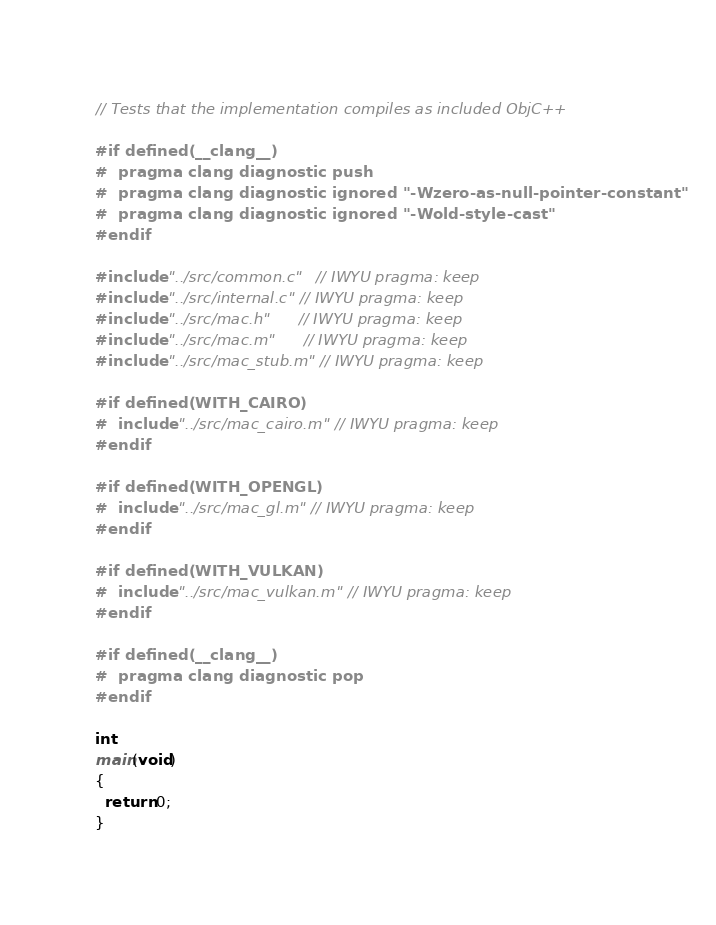<code> <loc_0><loc_0><loc_500><loc_500><_ObjectiveC_>
// Tests that the implementation compiles as included ObjC++

#if defined(__clang__)
#  pragma clang diagnostic push
#  pragma clang diagnostic ignored "-Wzero-as-null-pointer-constant"
#  pragma clang diagnostic ignored "-Wold-style-cast"
#endif

#include "../src/common.c"   // IWYU pragma: keep
#include "../src/internal.c" // IWYU pragma: keep
#include "../src/mac.h"      // IWYU pragma: keep
#include "../src/mac.m"      // IWYU pragma: keep
#include "../src/mac_stub.m" // IWYU pragma: keep

#if defined(WITH_CAIRO)
#  include "../src/mac_cairo.m" // IWYU pragma: keep
#endif

#if defined(WITH_OPENGL)
#  include "../src/mac_gl.m" // IWYU pragma: keep
#endif

#if defined(WITH_VULKAN)
#  include "../src/mac_vulkan.m" // IWYU pragma: keep
#endif

#if defined(__clang__)
#  pragma clang diagnostic pop
#endif

int
main(void)
{
  return 0;
}
</code> 